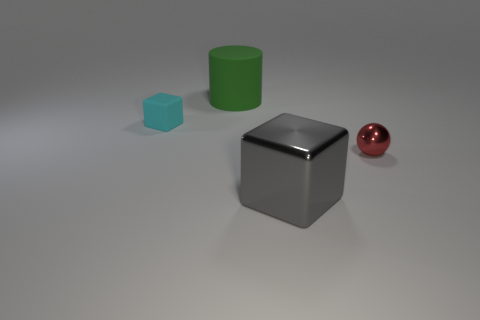What color is the big thing behind the tiny shiny ball?
Keep it short and to the point. Green. There is a cube in front of the ball; is its size the same as the matte object to the right of the cyan cube?
Make the answer very short. Yes. How many things are big gray rubber cylinders or cyan rubber cubes?
Keep it short and to the point. 1. There is a thing to the right of the large thing that is in front of the big green object; what is its material?
Offer a terse response. Metal. How many other objects have the same shape as the gray thing?
Offer a terse response. 1. What number of objects are cubes in front of the red shiny thing or blocks on the right side of the cyan rubber block?
Offer a very short reply. 1. There is a big object that is behind the tiny cyan cube; are there any large green matte objects behind it?
Make the answer very short. No. What is the shape of the gray metallic thing that is the same size as the cylinder?
Make the answer very short. Cube. How many things are either things that are in front of the red metal object or small gray cylinders?
Offer a terse response. 1. How many other objects are there of the same material as the cyan cube?
Your answer should be very brief. 1. 